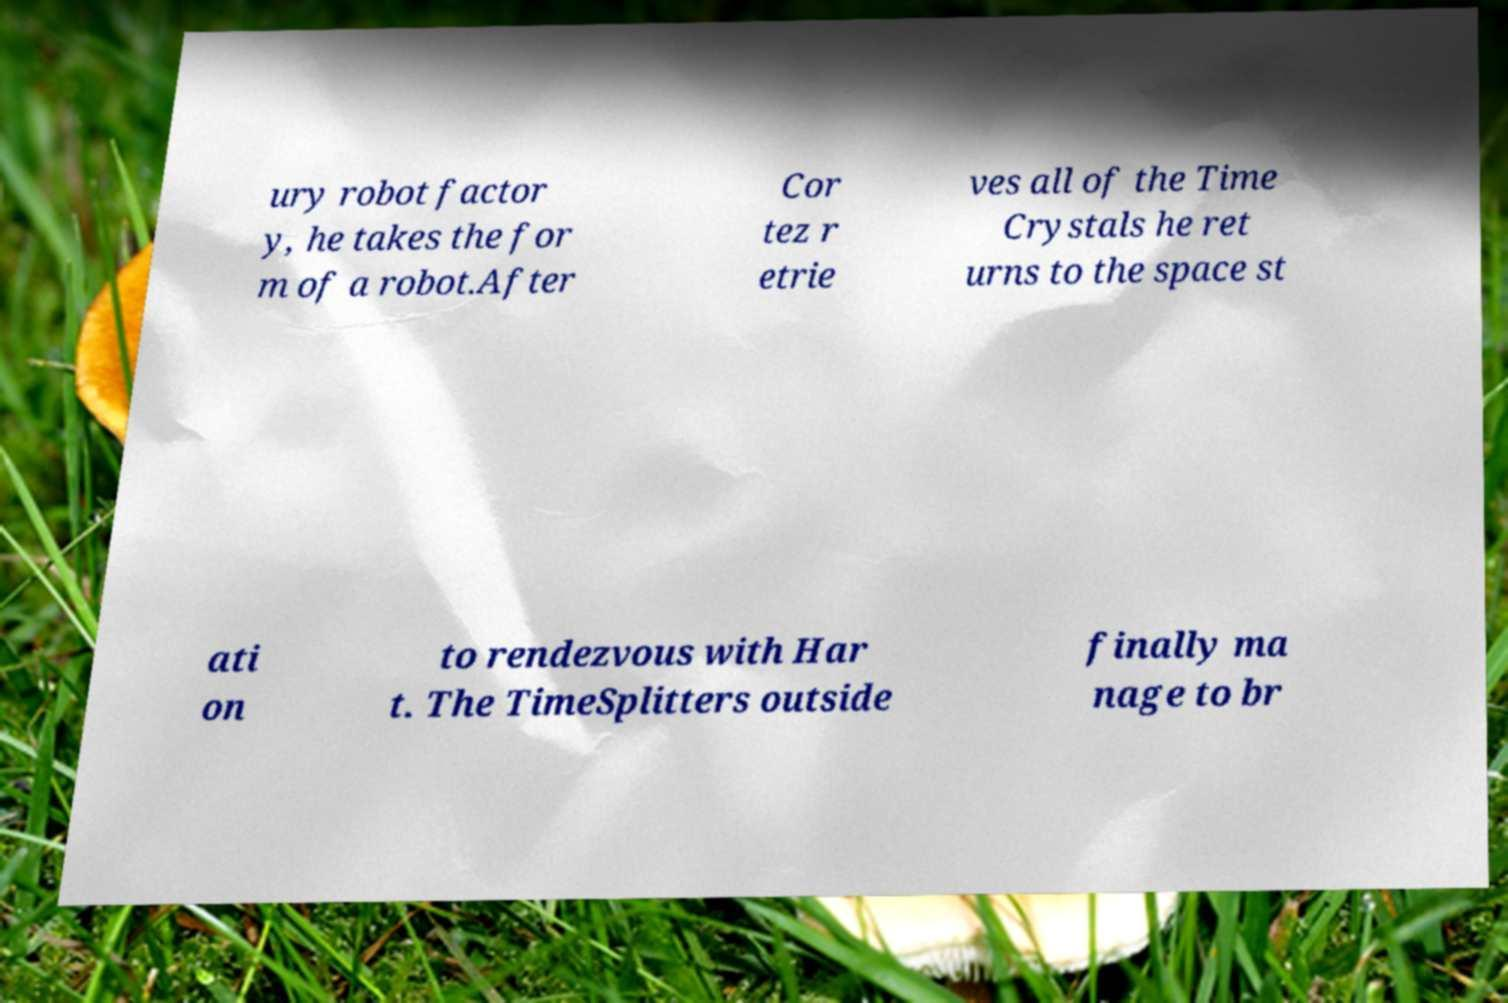What messages or text are displayed in this image? I need them in a readable, typed format. ury robot factor y, he takes the for m of a robot.After Cor tez r etrie ves all of the Time Crystals he ret urns to the space st ati on to rendezvous with Har t. The TimeSplitters outside finally ma nage to br 